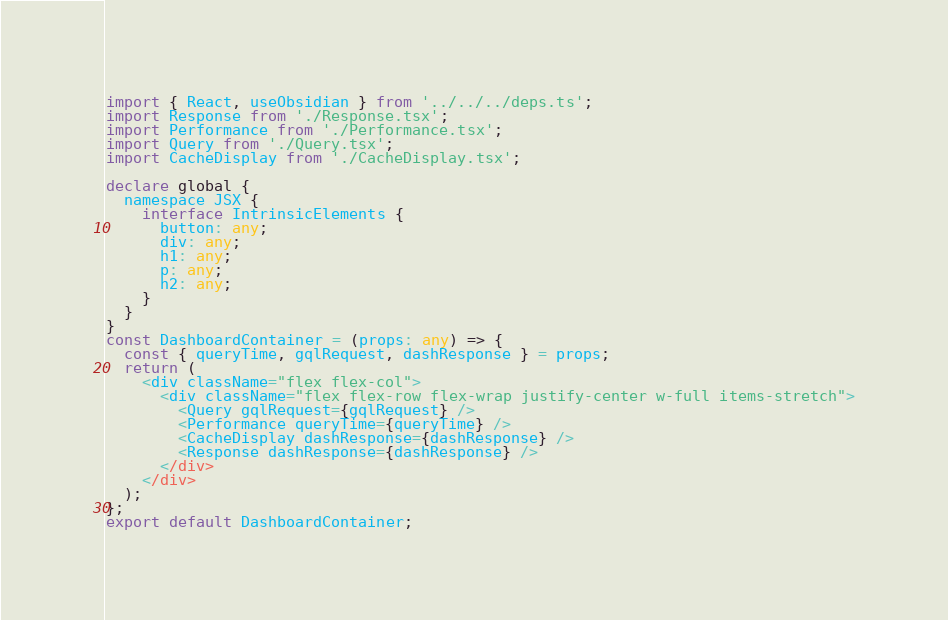<code> <loc_0><loc_0><loc_500><loc_500><_TypeScript_>import { React, useObsidian } from '../../../deps.ts';
import Response from './Response.tsx';
import Performance from './Performance.tsx';
import Query from './Query.tsx';
import CacheDisplay from './CacheDisplay.tsx';

declare global {
  namespace JSX {
    interface IntrinsicElements {
      button: any;
      div: any;
      h1: any;
      p: any;
      h2: any;
    }
  }
}
const DashboardContainer = (props: any) => {
  const { queryTime, gqlRequest, dashResponse } = props;
  return (
    <div className="flex flex-col">
      <div className="flex flex-row flex-wrap justify-center w-full items-stretch">
        <Query gqlRequest={gqlRequest} />
        <Performance queryTime={queryTime} />
        <CacheDisplay dashResponse={dashResponse} />
        <Response dashResponse={dashResponse} />
      </div>
    </div>
  );
};
export default DashboardContainer;
</code> 